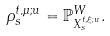<formula> <loc_0><loc_0><loc_500><loc_500>\rho _ { s } ^ { t , \mu ; u } = \mathbb { P } _ { X _ { s } ^ { t , \xi ; u } } ^ { W } .</formula> 